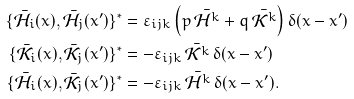<formula> <loc_0><loc_0><loc_500><loc_500>\{ \bar { \mathcal { H } _ { i } } ( x ) , \bar { \mathcal { H } _ { j } } ( x ^ { \prime } ) \} ^ { * } & = \varepsilon _ { i j k } \left ( p \, \bar { \mathcal { H } ^ { k } } + q \, \bar { \mathcal { K } ^ { k } } \right ) \delta ( x - x ^ { \prime } ) \\ \{ \bar { \mathcal { K } _ { i } } ( x ) , \bar { \mathcal { K } _ { j } } ( x ^ { \prime } ) \} ^ { * } & = - \varepsilon _ { i j k } \, \bar { \mathcal { K } ^ { k } } \, \delta ( x - x ^ { \prime } ) \\ \{ \bar { \mathcal { H } _ { i } } ( x ) , \bar { \mathcal { K } _ { j } } ( x ^ { \prime } ) \} ^ { * } & = - \varepsilon _ { i j k } \, \bar { \mathcal { H } ^ { k } } \, \delta ( x - x ^ { \prime } ) . \\</formula> 